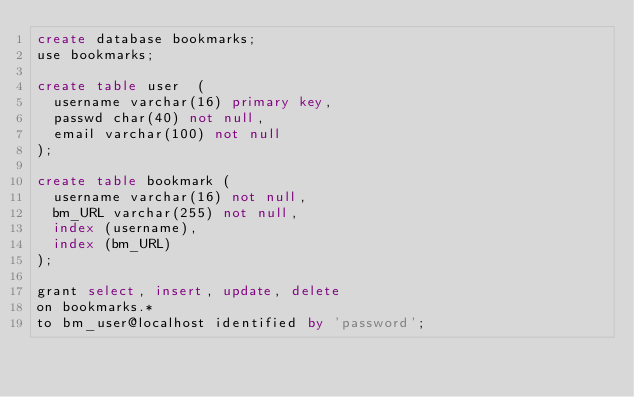<code> <loc_0><loc_0><loc_500><loc_500><_SQL_>create database bookmarks;
use bookmarks;

create table user  (
  username varchar(16) primary key,
  passwd char(40) not null,
  email varchar(100) not null
);

create table bookmark (
  username varchar(16) not null,
  bm_URL varchar(255) not null,
  index (username),
  index (bm_URL)
);

grant select, insert, update, delete
on bookmarks.*
to bm_user@localhost identified by 'password';
</code> 